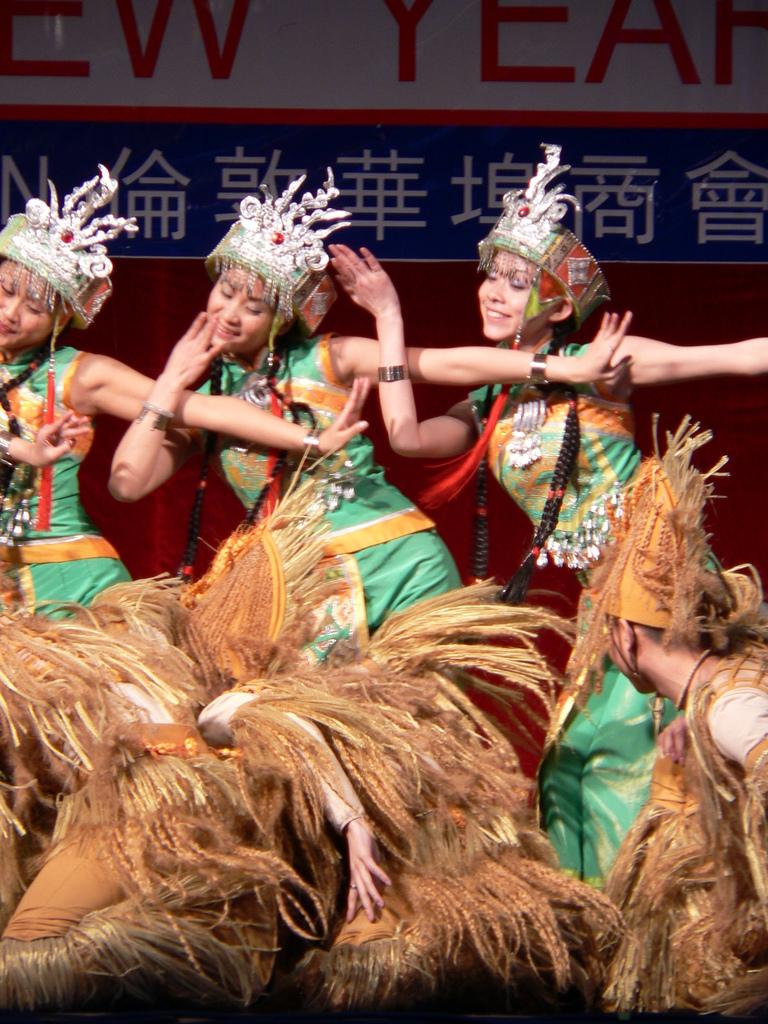What is the main subject of the image? The main subject of the image is a group of people. Where are the people located in the image? The people are on the floor in the image. What are the people wearing in the image? The people are wearing costumes in the image. What else can be seen in the background of the image? There is a curtain visible in the image, as well as a board with text. What type of cherry is hanging from the curtain in the image? There is no cherry present in the image, and therefore no such object can be observed hanging from the curtain. 